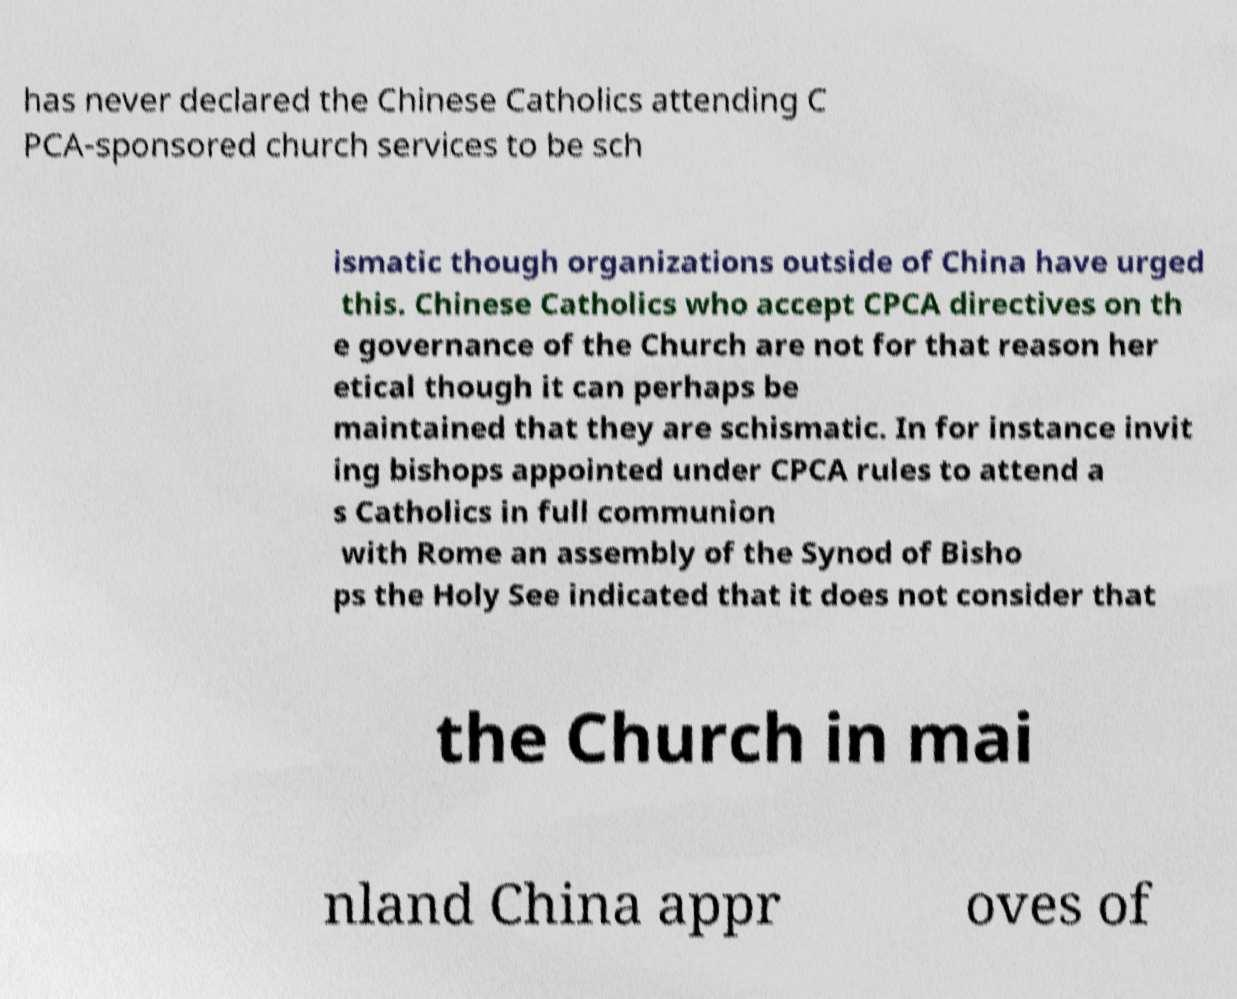Could you extract and type out the text from this image? has never declared the Chinese Catholics attending C PCA-sponsored church services to be sch ismatic though organizations outside of China have urged this. Chinese Catholics who accept CPCA directives on th e governance of the Church are not for that reason her etical though it can perhaps be maintained that they are schismatic. In for instance invit ing bishops appointed under CPCA rules to attend a s Catholics in full communion with Rome an assembly of the Synod of Bisho ps the Holy See indicated that it does not consider that the Church in mai nland China appr oves of 